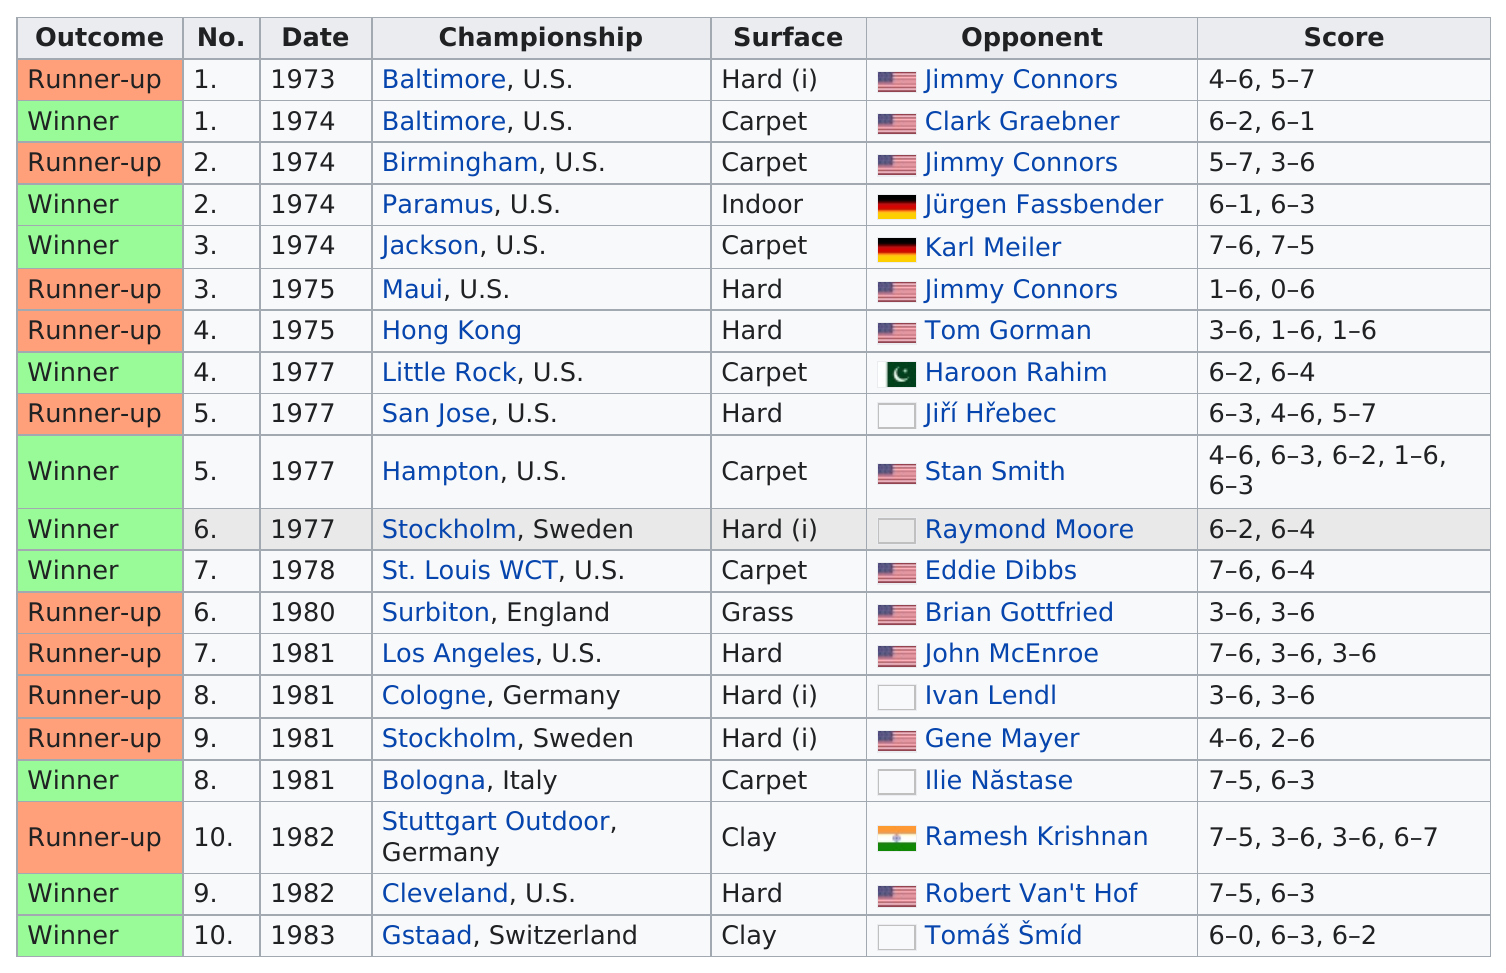Identify some key points in this picture. Jimmy Connors was the opponent who was competed against the most often. Seven different countries are listed. Two consecutive championships occurred in Baltimore, United States. Jürgen Fassbender's opponent who was listed prior to him is Jimmy Connors. Jürgen Fassbender was the first person this person played on an indoor surface. 